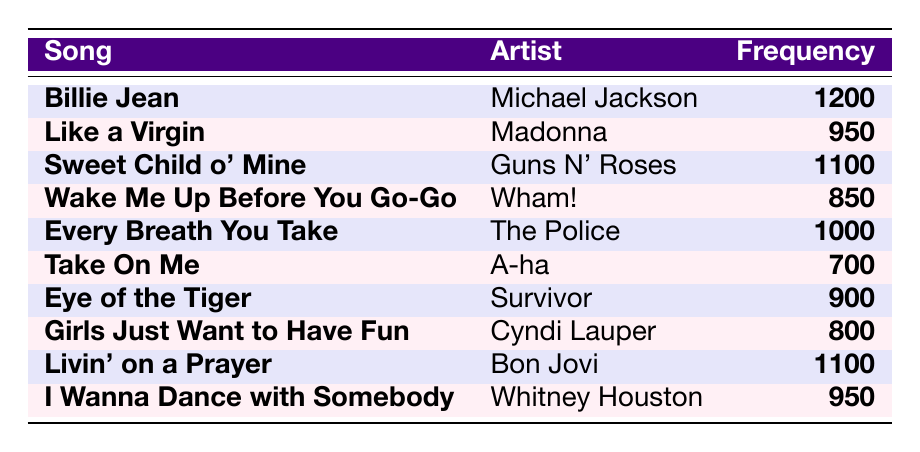What is the song with the highest radio airplay frequency? The table lists songs along with their airplay frequencies. By scanning through the frequency column, "Billie Jean" by Michael Jackson has the highest frequency of 1200.
Answer: Billie Jean Which artist performed "Sweet Child o' Mine"? In the table, "Sweet Child o' Mine" is listed in the first column and is associated with the artist "Guns N' Roses" in the second column.
Answer: Guns N' Roses What is the total airplay frequency of "Like a Virgin" and "I Wanna Dance with Somebody"? To find the total, we add the frequencies of both songs: Like a Virgin has a frequency of 950 and I Wanna Dance with Somebody has a frequency of 950. Thus, total = 950 + 950 = 1900.
Answer: 1900 Does "Eye of the Tiger" have a higher airplay frequency than "Girls Just Want to Have Fun"? Checking the table, "Eye of the Tiger" has a frequency of 900 while "Girls Just Want to Have Fun" has a frequency of 800. Since 900 is greater than 800, the statement is true.
Answer: Yes What is the average airplay frequency of all the songs listed in the table? To find the average, we first sum all the frequencies: 1200 + 950 + 1100 + 850 + 1000 + 700 + 900 + 800 + 1100 + 950 = 10500. There are 10 songs, so the average is 10500 divided by 10, which equals 1050.
Answer: 1050 How many songs have an airplay frequency of 900 or higher? By analyzing the frequency column, the songs with frequencies of 900 or higher are "Billie Jean", "Sweet Child o' Mine", "Every Breath You Take", "Livin' on a Prayer", and "I Wanna Dance with Somebody". This gives a total of 5 songs.
Answer: 5 Which song has a lower frequency: "Take On Me" or "Wake Me Up Before You Go-Go"? In the table, "Take On Me" has a frequency of 700 and "Wake Me Up Before You Go-Go" has a frequency of 850. Since 700 is less than 850, "Take On Me" has the lower frequency.
Answer: Take On Me List the songs that have a frequency greater than 1000. According to the table, the songs with frequencies greater than 1000 are "Billie Jean" (1200), "Sweet Child o' Mine" (1100), and "Livin' on a Prayer" (1100).
Answer: Billie Jean, Sweet Child o' Mine, Livin' on a Prayer 